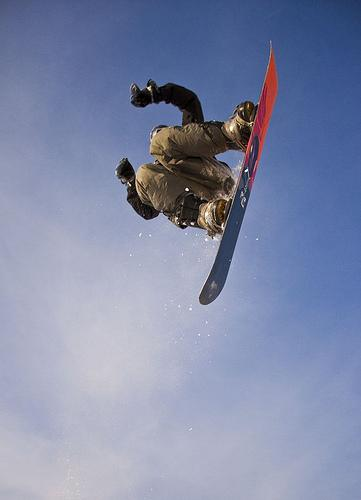Provide an assessment on the sentiment or emotion conveyed by the snowboarding scene. The image conveys a sense of excitement, thrill, and adventure, enhanced by the athleticism of the snowboarder performing a daring trick. Evaluate the quality of the image based on its clarity and provided information. The image is of high quality, providing clear and specific information about the scene's elements and their various aspects such as colors, sizes, and positions. Enumerate the clothing items as well as accessories, along with their colors, worn by the snowboarder. The snowboarder is wearing tan pants, a black jacket, black gloves, and boots with shoe straps on the snowboard. Count and describe the number of objects and persons in the photo. There are 10 objects and one person in the photo, which include a snowboarder, a blue and red snowboard, gloves, helmet, pants, jacket, boots, shoe straps, chunks of snow, and a part of a board's edge. Deduce the time of day and weather conditions in the image based on the sky's appearance. Based on the clear blue sky and few scattered clouds, it appears to be a sunny day with good visibility, likely sometime around midday or early afternoon. What type of movement do you infer the snowboarder is making, based on the falling snow around them? The snowboarder seems to be making a high jump or performing an aerial trick as they are suspended in the air with snow falling around them. Analyze the interaction between the snowboarder and their equipment, and infer the level of skill required for the trick being performed. The snowboarder appears to be well-balanced and in control of their equipment while performing an aerial trick, indicating a high level of skill and experience in snowboarding. Mention the colors of the snowboard and describe its position relative to the snowboarder. The snowboard is blue and red, and is positioned beneath the snowboarder in the air. What is the primary sport or activity taking place in the image? The primary sport in the image is snowboarding. Please provide a brief narrative of the scene, including the sky and the main person. A person, likely male, is snowboarding mid-air against the backdrop of a clear blue sky with a few white clouds scattered around. Is there any visible snow in the air in the image? Yes, there are little pieces or chunks of snow in the air. As per the image, is the snowboarder wearing any gloves? If yes, what color? Yes, the snowboarder is wearing black gloves. Based on the image, is the snowboarder wearing a helmet? Yes, there is a part of a helmet visible. What is the primary activity happening in the image? snowboarding What color is the snowboarder's pants? tan Are there purple shoes on the snowboarder? No, it's not mentioned in the image. Identify the color of the gloves on the snowboarder and the pieces of snow that appear falling. The gloves are black, and the snow is white. What color are the clouds in the sky according to the information? The clouds are white in color. Is the snowboard green and yellow in color? The snowboard is described as having red and blue colors, not green and yellow. What kind of trick is the snowboarder performing in the image? The specific trick is not identifiable. Which of these elements is not a part of the image? A) Thick clouds B) Black gloves C) Blue sky A) Thick clouds What is the gender of the person doing the trick on the snowboard? The gender is not identifiable or specified. Is there any writing on the snowboard? If yes, what color is it? Yes, there is white writing on the bottom of the snowboard. Are there any shoe straps visible on the snowboard? If yes, what kind of shoe are they attached to? Yes, there are shoe straps visible on the snowboard and they are attached to boots. Looking at the image, is there any part of a helmet visible? Yes, a part of a helmet is visible above the knee. What color is the sky in the image and is it clear or cloudy? The sky is blue and clear. What type of sports usually involve snow and athletes in the air like this image? winter sports In this image, can you find a snowboarder performing a trick and describe the color of the snowboard? Yes, the snowboard is blue and orange (or red and blue) What type of footwear is the snowboarder wearing and are there any straps on it? The snowboarder is wearing boots with shoe straps. Provide a vivid description of the scene with the snowboarder up in the air. A snowboarder is soaring through the air against a clear blue sky, performing a trick on an orange and blue snowboard while wearing tan pants, a black jacket, and black gloves. Are there raindrops falling from the sky? The image describes snow falling, not raindrops. Is the sky filled with dark stormy clouds? The sky is described as clear and blue, with white clouds, not dark and stormy. Describe the snowboarder's outfit in the image. The snowboarder is wearing tan pants, a black jacket, and black gloves. Is the snowboarder wearing white gloves? The snowboarder is described as wearing black gloves, not white ones. 